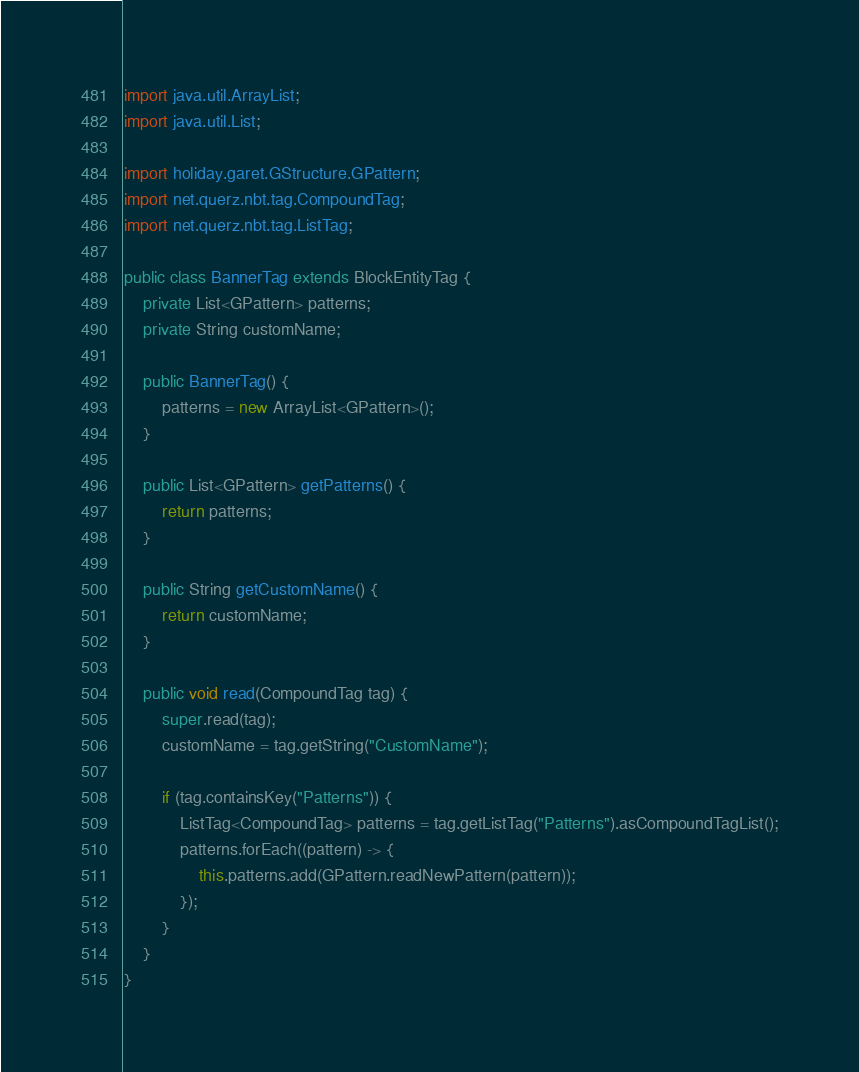<code> <loc_0><loc_0><loc_500><loc_500><_Java_>import java.util.ArrayList;
import java.util.List;

import holiday.garet.GStructure.GPattern;
import net.querz.nbt.tag.CompoundTag;
import net.querz.nbt.tag.ListTag;

public class BannerTag extends BlockEntityTag {
	private List<GPattern> patterns;
	private String customName;
	
	public BannerTag() {
		patterns = new ArrayList<GPattern>();
	}
	
	public List<GPattern> getPatterns() {
		return patterns;
	}
	
	public String getCustomName() {
		return customName;
	}
	
	public void read(CompoundTag tag) {
		super.read(tag);
		customName = tag.getString("CustomName");
		
		if (tag.containsKey("Patterns")) {
			ListTag<CompoundTag> patterns = tag.getListTag("Patterns").asCompoundTagList();
			patterns.forEach((pattern) -> {
				this.patterns.add(GPattern.readNewPattern(pattern));
			});
		}
	}
}
</code> 